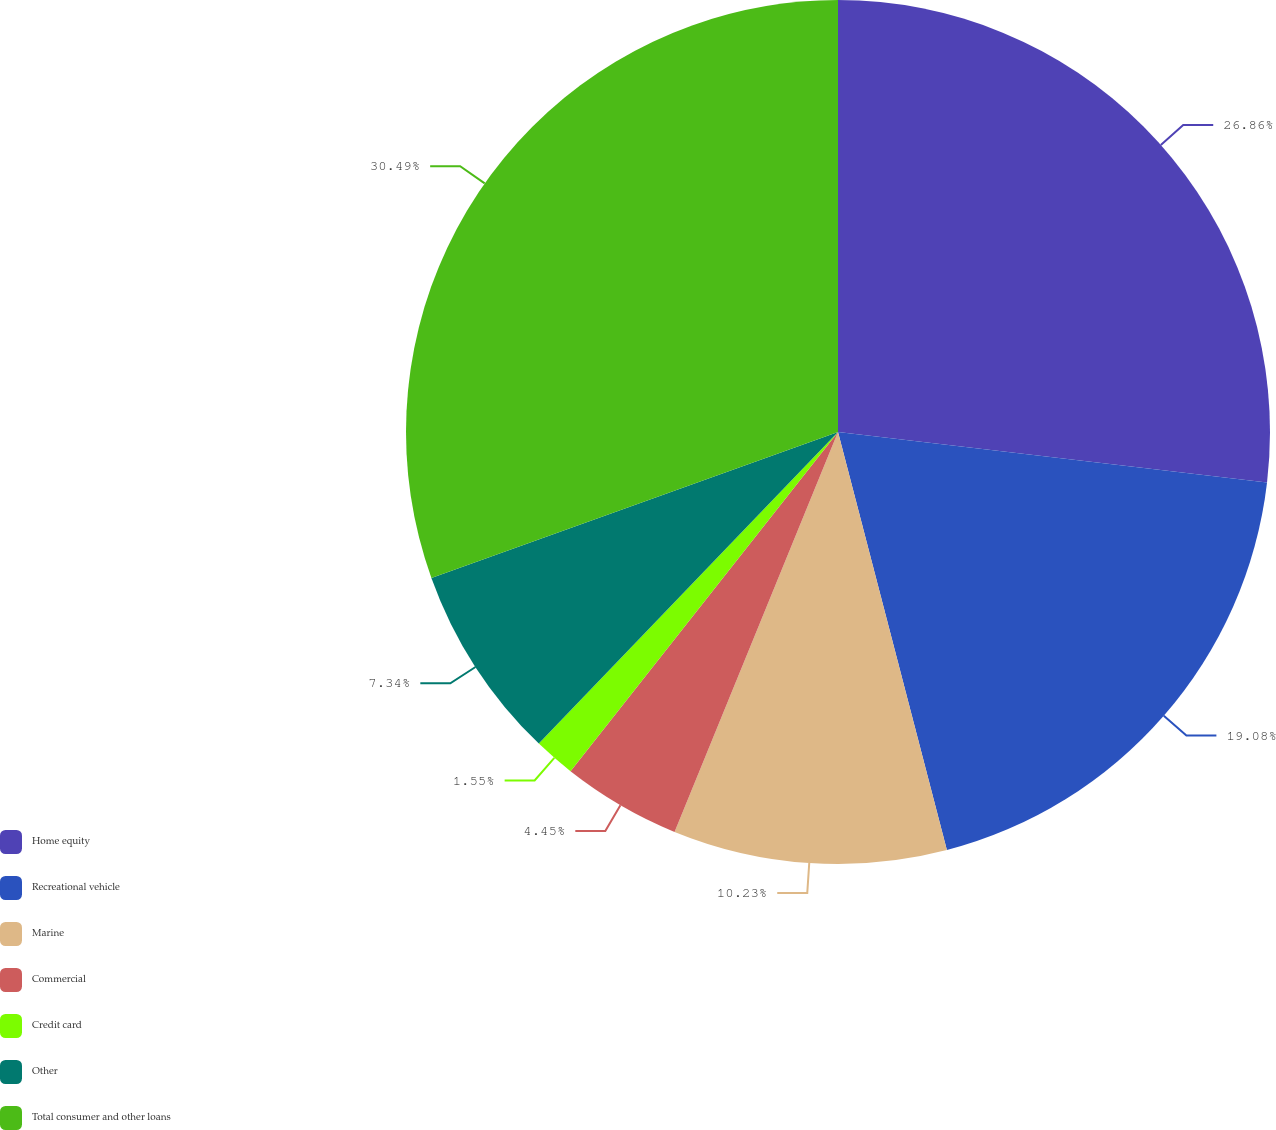<chart> <loc_0><loc_0><loc_500><loc_500><pie_chart><fcel>Home equity<fcel>Recreational vehicle<fcel>Marine<fcel>Commercial<fcel>Credit card<fcel>Other<fcel>Total consumer and other loans<nl><fcel>26.86%<fcel>19.08%<fcel>10.23%<fcel>4.45%<fcel>1.55%<fcel>7.34%<fcel>30.48%<nl></chart> 